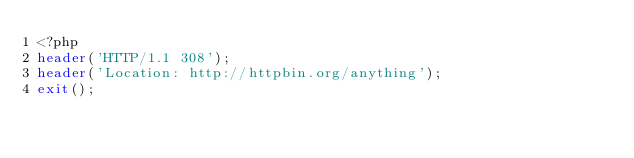Convert code to text. <code><loc_0><loc_0><loc_500><loc_500><_PHP_><?php
header('HTTP/1.1 308');
header('Location: http://httpbin.org/anything');
exit();</code> 